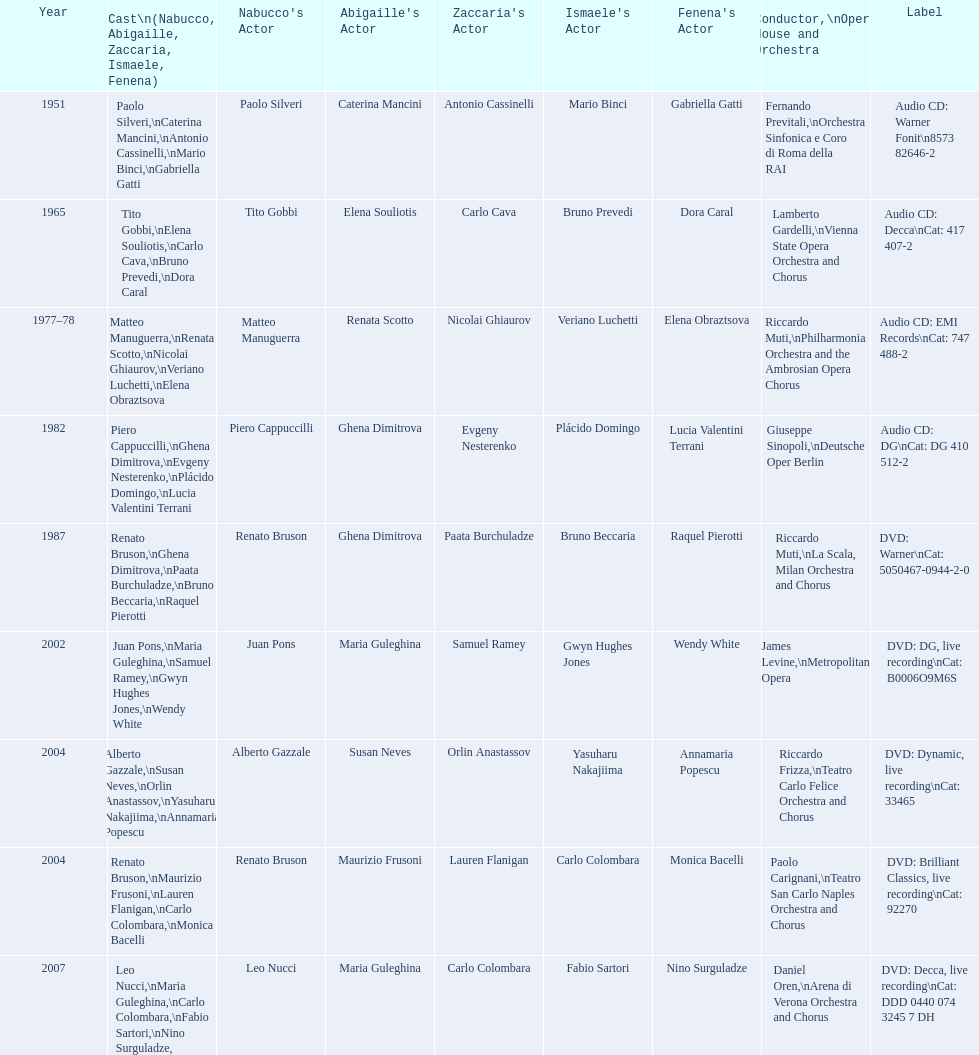How many recordings of nabucco have been made? 9. 